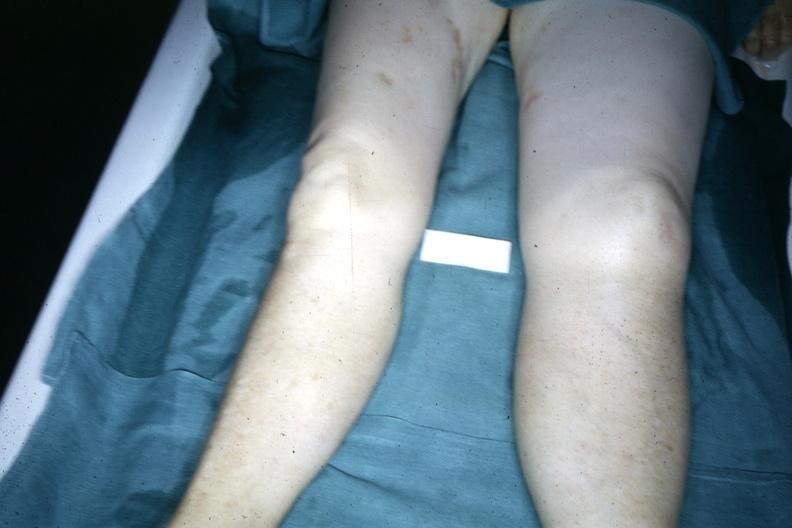re extremities present?
Answer the question using a single word or phrase. Yes 